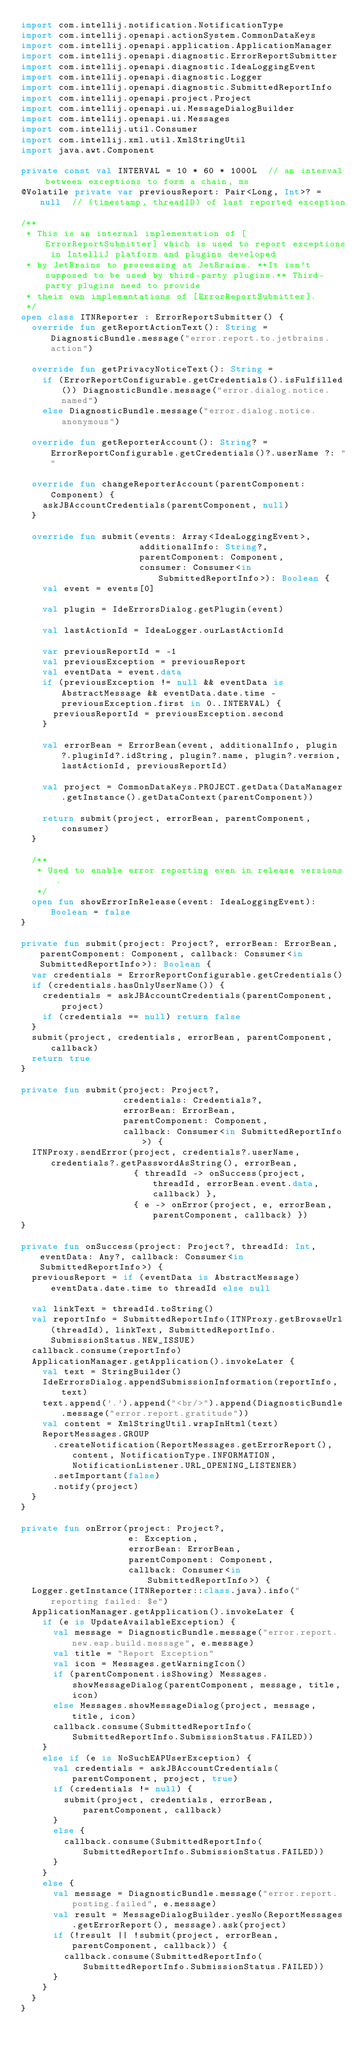<code> <loc_0><loc_0><loc_500><loc_500><_Kotlin_>import com.intellij.notification.NotificationType
import com.intellij.openapi.actionSystem.CommonDataKeys
import com.intellij.openapi.application.ApplicationManager
import com.intellij.openapi.diagnostic.ErrorReportSubmitter
import com.intellij.openapi.diagnostic.IdeaLoggingEvent
import com.intellij.openapi.diagnostic.Logger
import com.intellij.openapi.diagnostic.SubmittedReportInfo
import com.intellij.openapi.project.Project
import com.intellij.openapi.ui.MessageDialogBuilder
import com.intellij.openapi.ui.Messages
import com.intellij.util.Consumer
import com.intellij.xml.util.XmlStringUtil
import java.awt.Component

private const val INTERVAL = 10 * 60 * 1000L  // an interval between exceptions to form a chain, ms
@Volatile private var previousReport: Pair<Long, Int>? = null  // (timestamp, threadID) of last reported exception

/**
 * This is an internal implementation of [ErrorReportSubmitter] which is used to report exceptions in IntelliJ platform and plugins developed
 * by JetBrains to processing at JetBrains. **It isn't supposed to be used by third-party plugins.** Third-party plugins need to provide
 * their own implementations of [ErrorReportSubmitter].
 */
open class ITNReporter : ErrorReportSubmitter() {
  override fun getReportActionText(): String = DiagnosticBundle.message("error.report.to.jetbrains.action")

  override fun getPrivacyNoticeText(): String =
    if (ErrorReportConfigurable.getCredentials().isFulfilled()) DiagnosticBundle.message("error.dialog.notice.named")
    else DiagnosticBundle.message("error.dialog.notice.anonymous")

  override fun getReporterAccount(): String? = ErrorReportConfigurable.getCredentials()?.userName ?: ""

  override fun changeReporterAccount(parentComponent: Component) {
    askJBAccountCredentials(parentComponent, null)
  }

  override fun submit(events: Array<IdeaLoggingEvent>,
                      additionalInfo: String?,
                      parentComponent: Component,
                      consumer: Consumer<in SubmittedReportInfo>): Boolean {
    val event = events[0]

    val plugin = IdeErrorsDialog.getPlugin(event)

    val lastActionId = IdeaLogger.ourLastActionId

    var previousReportId = -1
    val previousException = previousReport
    val eventData = event.data
    if (previousException != null && eventData is AbstractMessage && eventData.date.time - previousException.first in 0..INTERVAL) {
      previousReportId = previousException.second
    }

    val errorBean = ErrorBean(event, additionalInfo, plugin?.pluginId?.idString, plugin?.name, plugin?.version, lastActionId, previousReportId)

    val project = CommonDataKeys.PROJECT.getData(DataManager.getInstance().getDataContext(parentComponent))

    return submit(project, errorBean, parentComponent, consumer)
  }

  /**
   * Used to enable error reporting even in release versions.
   */
  open fun showErrorInRelease(event: IdeaLoggingEvent): Boolean = false
}

private fun submit(project: Project?, errorBean: ErrorBean, parentComponent: Component, callback: Consumer<in SubmittedReportInfo>): Boolean {
  var credentials = ErrorReportConfigurable.getCredentials()
  if (credentials.hasOnlyUserName()) {
    credentials = askJBAccountCredentials(parentComponent, project)
    if (credentials == null) return false
  }
  submit(project, credentials, errorBean, parentComponent, callback)
  return true
}

private fun submit(project: Project?,
                   credentials: Credentials?,
                   errorBean: ErrorBean,
                   parentComponent: Component,
                   callback: Consumer<in SubmittedReportInfo>) {
  ITNProxy.sendError(project, credentials?.userName, credentials?.getPasswordAsString(), errorBean,
                     { threadId -> onSuccess(project, threadId, errorBean.event.data, callback) },
                     { e -> onError(project, e, errorBean, parentComponent, callback) })
}

private fun onSuccess(project: Project?, threadId: Int, eventData: Any?, callback: Consumer<in SubmittedReportInfo>) {
  previousReport = if (eventData is AbstractMessage) eventData.date.time to threadId else null

  val linkText = threadId.toString()
  val reportInfo = SubmittedReportInfo(ITNProxy.getBrowseUrl(threadId), linkText, SubmittedReportInfo.SubmissionStatus.NEW_ISSUE)
  callback.consume(reportInfo)
  ApplicationManager.getApplication().invokeLater {
    val text = StringBuilder()
    IdeErrorsDialog.appendSubmissionInformation(reportInfo, text)
    text.append('.').append("<br/>").append(DiagnosticBundle.message("error.report.gratitude"))
    val content = XmlStringUtil.wrapInHtml(text)
    ReportMessages.GROUP
      .createNotification(ReportMessages.getErrorReport(), content, NotificationType.INFORMATION, NotificationListener.URL_OPENING_LISTENER)
      .setImportant(false)
      .notify(project)
  }
}

private fun onError(project: Project?,
                    e: Exception,
                    errorBean: ErrorBean,
                    parentComponent: Component,
                    callback: Consumer<in SubmittedReportInfo>) {
  Logger.getInstance(ITNReporter::class.java).info("reporting failed: $e")
  ApplicationManager.getApplication().invokeLater {
    if (e is UpdateAvailableException) {
      val message = DiagnosticBundle.message("error.report.new.eap.build.message", e.message)
      val title = "Report Exception"
      val icon = Messages.getWarningIcon()
      if (parentComponent.isShowing) Messages.showMessageDialog(parentComponent, message, title, icon)
      else Messages.showMessageDialog(project, message, title, icon)
      callback.consume(SubmittedReportInfo(SubmittedReportInfo.SubmissionStatus.FAILED))
    }
    else if (e is NoSuchEAPUserException) {
      val credentials = askJBAccountCredentials(parentComponent, project, true)
      if (credentials != null) {
        submit(project, credentials, errorBean, parentComponent, callback)
      }
      else {
        callback.consume(SubmittedReportInfo(SubmittedReportInfo.SubmissionStatus.FAILED))
      }
    }
    else {
      val message = DiagnosticBundle.message("error.report.posting.failed", e.message)
      val result = MessageDialogBuilder.yesNo(ReportMessages.getErrorReport(), message).ask(project)
      if (!result || !submit(project, errorBean, parentComponent, callback)) {
        callback.consume(SubmittedReportInfo(SubmittedReportInfo.SubmissionStatus.FAILED))
      }
    }
  }
}</code> 